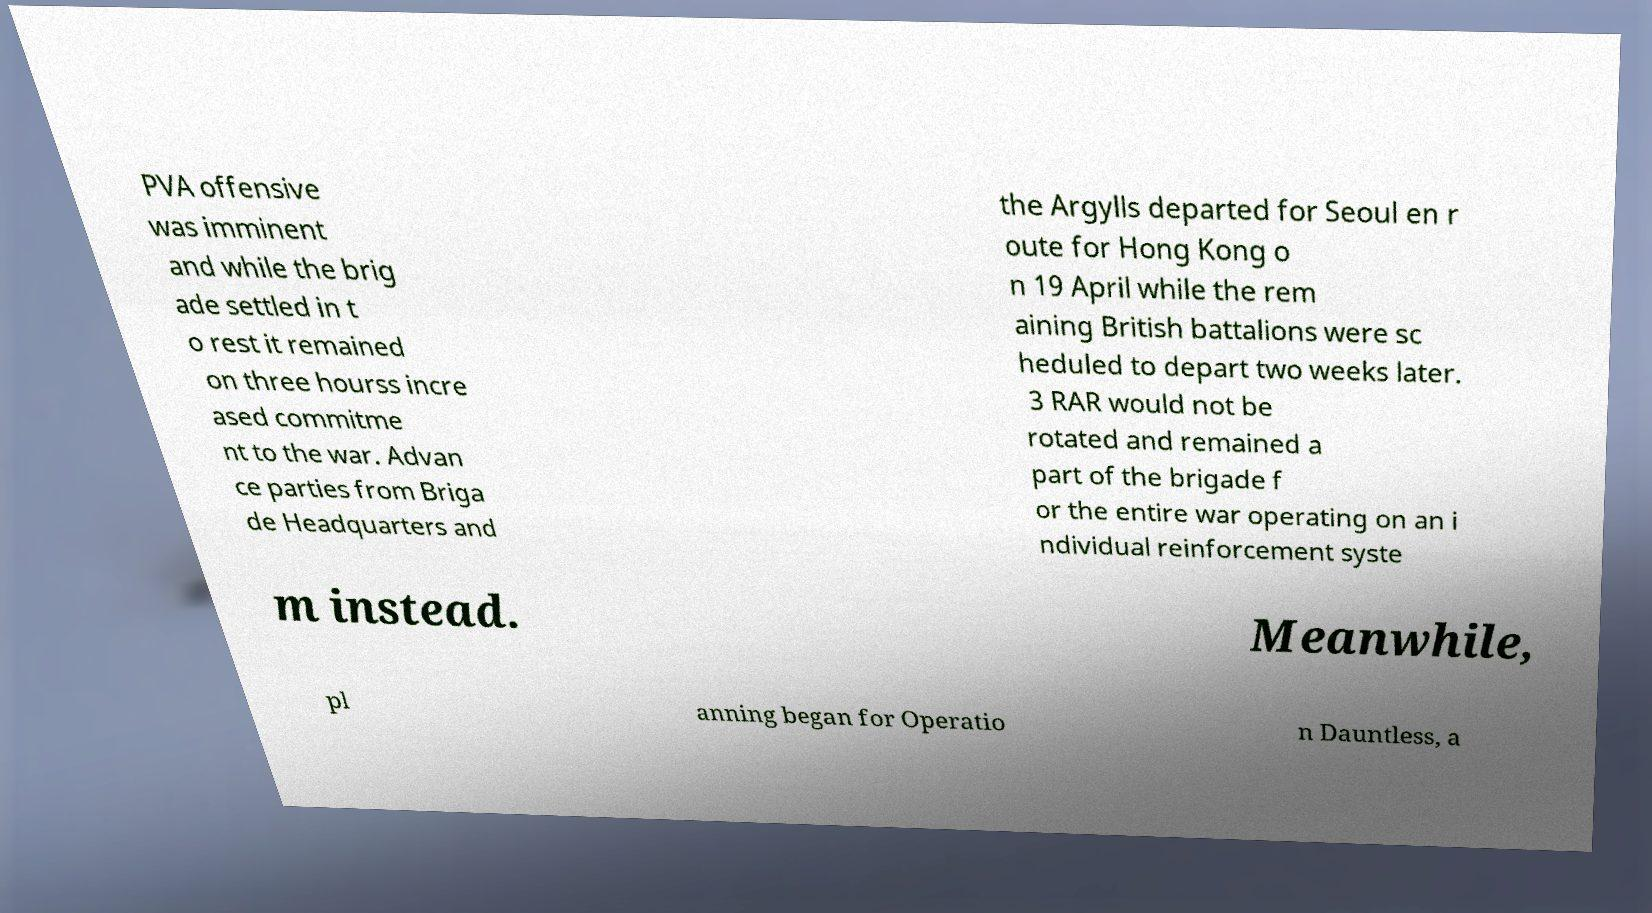Can you read and provide the text displayed in the image?This photo seems to have some interesting text. Can you extract and type it out for me? PVA offensive was imminent and while the brig ade settled in t o rest it remained on three hourss incre ased commitme nt to the war. Advan ce parties from Briga de Headquarters and the Argylls departed for Seoul en r oute for Hong Kong o n 19 April while the rem aining British battalions were sc heduled to depart two weeks later. 3 RAR would not be rotated and remained a part of the brigade f or the entire war operating on an i ndividual reinforcement syste m instead. Meanwhile, pl anning began for Operatio n Dauntless, a 